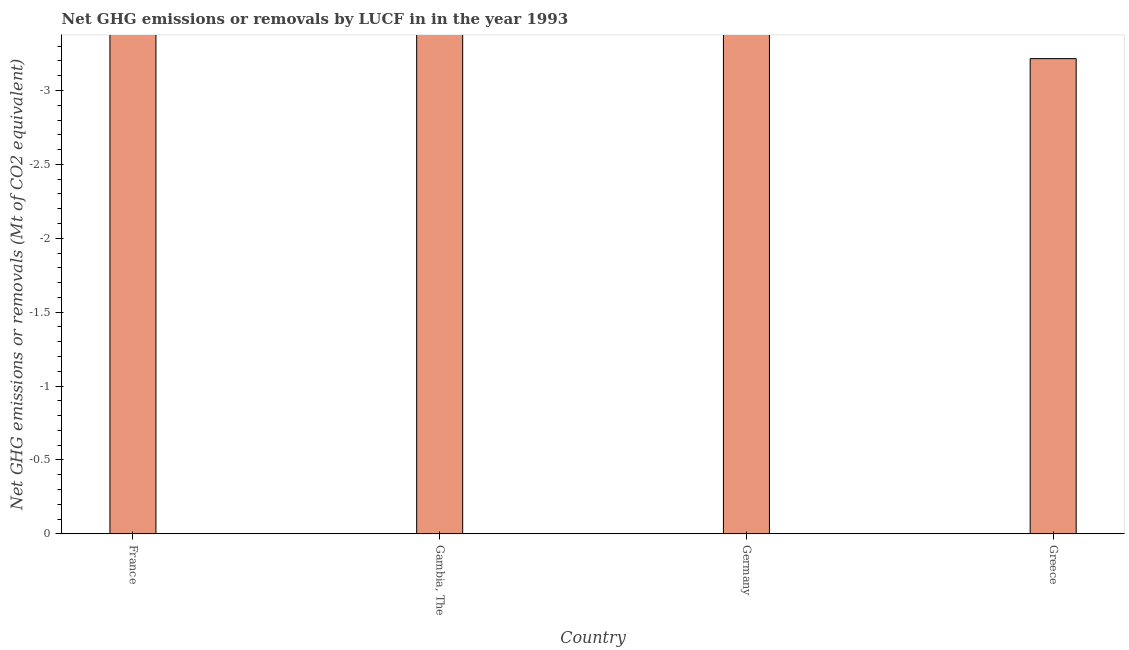Does the graph contain any zero values?
Your answer should be compact. Yes. What is the title of the graph?
Ensure brevity in your answer.  Net GHG emissions or removals by LUCF in in the year 1993. What is the label or title of the X-axis?
Make the answer very short. Country. What is the label or title of the Y-axis?
Ensure brevity in your answer.  Net GHG emissions or removals (Mt of CO2 equivalent). Across all countries, what is the minimum ghg net emissions or removals?
Offer a very short reply. 0. What is the sum of the ghg net emissions or removals?
Provide a succinct answer. 0. What is the median ghg net emissions or removals?
Keep it short and to the point. 0. Are all the bars in the graph horizontal?
Your answer should be compact. No. What is the difference between two consecutive major ticks on the Y-axis?
Your answer should be compact. 0.5. What is the Net GHG emissions or removals (Mt of CO2 equivalent) in Gambia, The?
Your response must be concise. 0. What is the Net GHG emissions or removals (Mt of CO2 equivalent) in Germany?
Ensure brevity in your answer.  0. What is the Net GHG emissions or removals (Mt of CO2 equivalent) in Greece?
Ensure brevity in your answer.  0. 